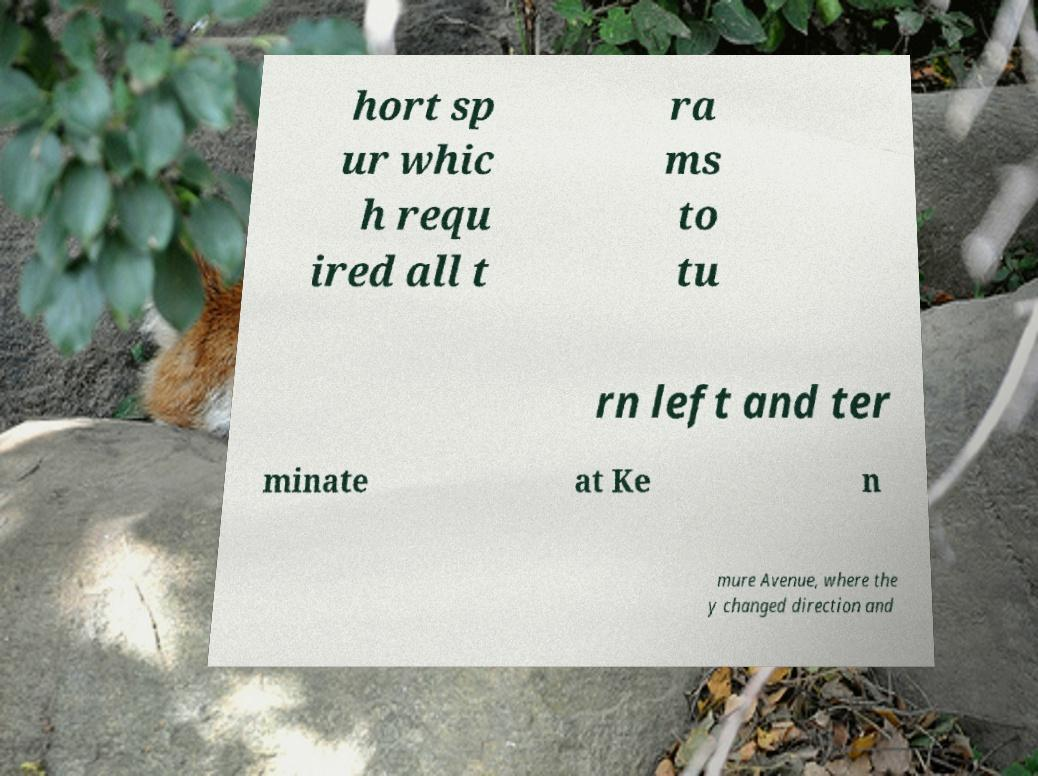What messages or text are displayed in this image? I need them in a readable, typed format. hort sp ur whic h requ ired all t ra ms to tu rn left and ter minate at Ke n mure Avenue, where the y changed direction and 